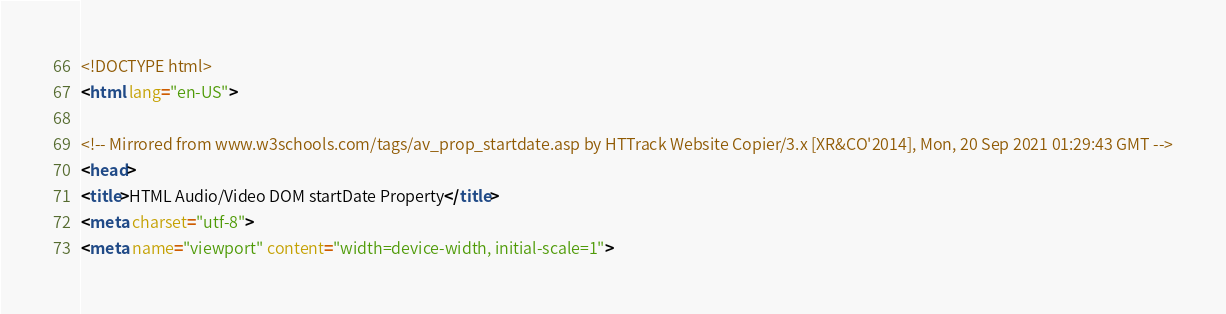Convert code to text. <code><loc_0><loc_0><loc_500><loc_500><_HTML_>
<!DOCTYPE html>
<html lang="en-US">

<!-- Mirrored from www.w3schools.com/tags/av_prop_startdate.asp by HTTrack Website Copier/3.x [XR&CO'2014], Mon, 20 Sep 2021 01:29:43 GMT -->
<head>
<title>HTML Audio/Video DOM startDate Property</title>
<meta charset="utf-8">
<meta name="viewport" content="width=device-width, initial-scale=1"></code> 